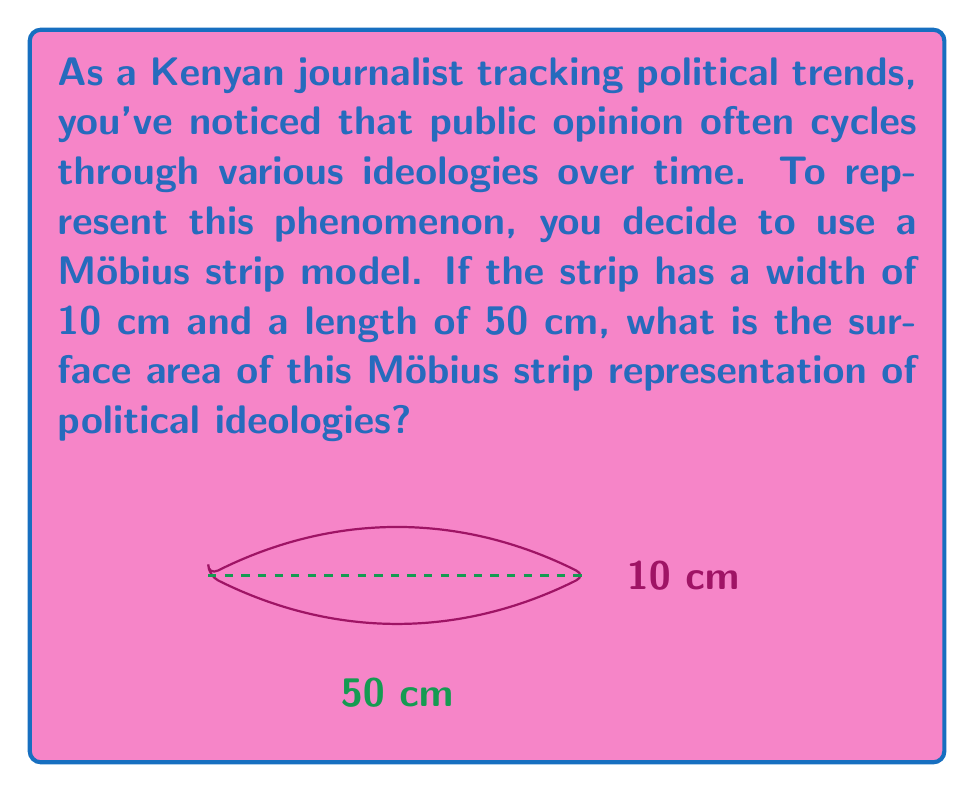Help me with this question. Let's approach this step-by-step:

1) The formula for the surface area of a Möbius strip is:

   $$A = \frac{1}{2} \times l \times w$$

   Where $l$ is the length and $w$ is the width of the strip before twisting.

2) We are given:
   - Width ($w$) = 10 cm
   - Length ($l$) = 50 cm

3) Let's substitute these values into our formula:

   $$A = \frac{1}{2} \times 50 \times 10$$

4) Now, let's calculate:

   $$A = \frac{1}{2} \times 500 = 250$$

5) Therefore, the surface area of the Möbius strip is 250 square centimeters.

This Möbius strip representation effectively shows how political ideologies and public opinion can seem to move in a cycle, yet end up in a different position after a complete revolution, much like tracing a path on a Möbius strip.
Answer: 250 cm² 